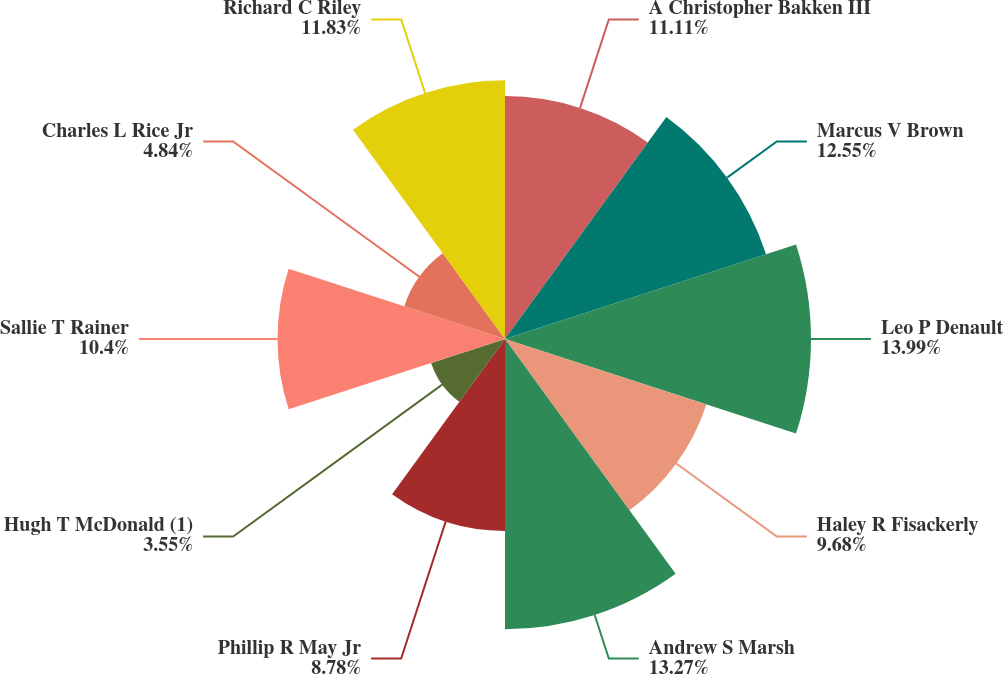Convert chart. <chart><loc_0><loc_0><loc_500><loc_500><pie_chart><fcel>A Christopher Bakken III<fcel>Marcus V Brown<fcel>Leo P Denault<fcel>Haley R Fisackerly<fcel>Andrew S Marsh<fcel>Phillip R May Jr<fcel>Hugh T McDonald (1)<fcel>Sallie T Rainer<fcel>Charles L Rice Jr<fcel>Richard C Riley<nl><fcel>11.11%<fcel>12.55%<fcel>13.99%<fcel>9.68%<fcel>13.27%<fcel>8.78%<fcel>3.55%<fcel>10.4%<fcel>4.84%<fcel>11.83%<nl></chart> 